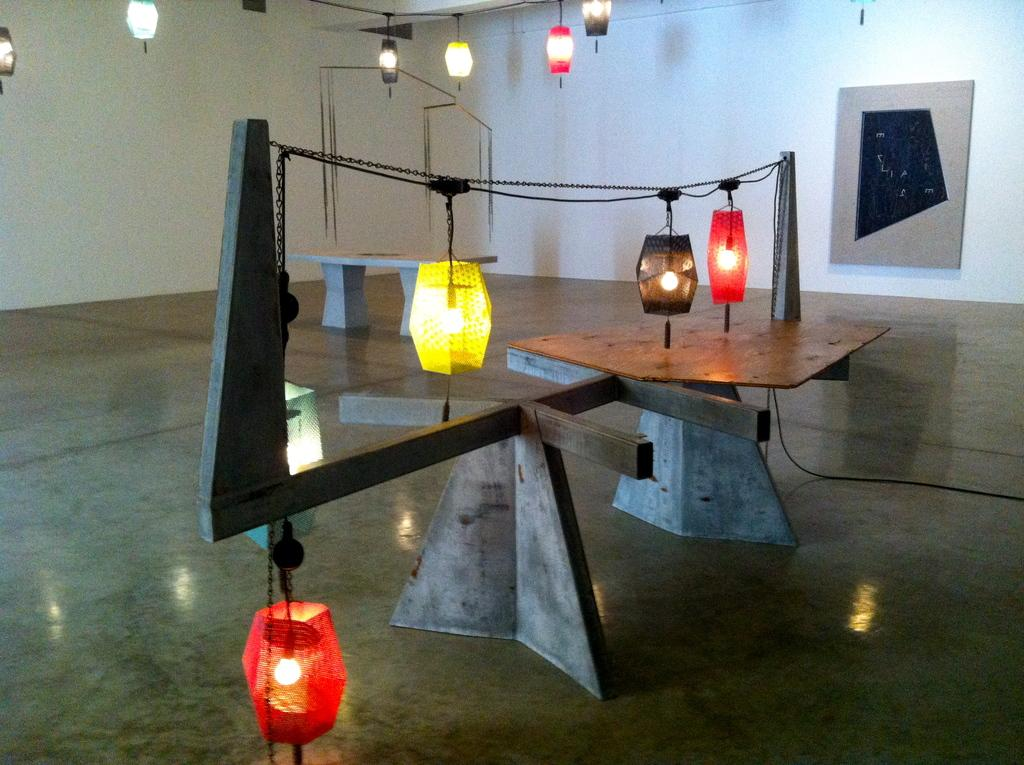What type of decorations are present in the image? There are colorful lanterns in the image. How are the lanterns arranged or connected? The lanterns are attached to a rope. What is the color and texture of the object in the image? The object is grey and brown in color. What is the board in the image attached to? The board is attached to a white wall. Can you tell me how many squirrels are holding the cord in the image? There are no squirrels present in the image, nor is there a cord for them to hold. 